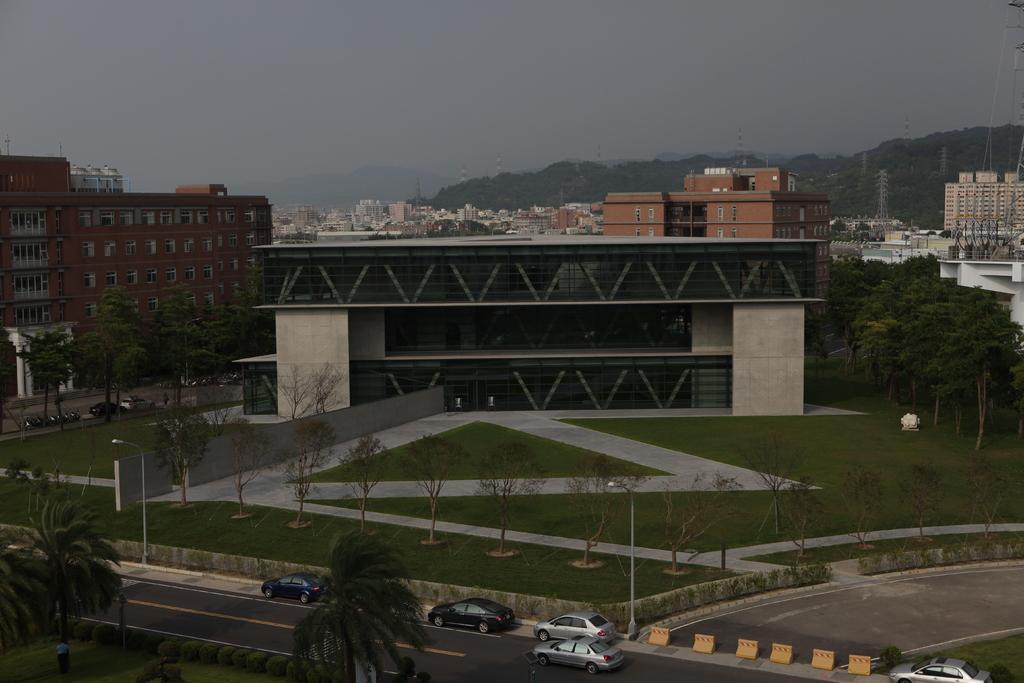In one or two sentences, can you explain what this image depicts? In this image we can see some buildings. On the bottom of the image we can see some vehicles on the road. We can also see some pants, grass, street poles and some trees. On the backside we can see the some towers, hills and the sky which looks cloudy. 